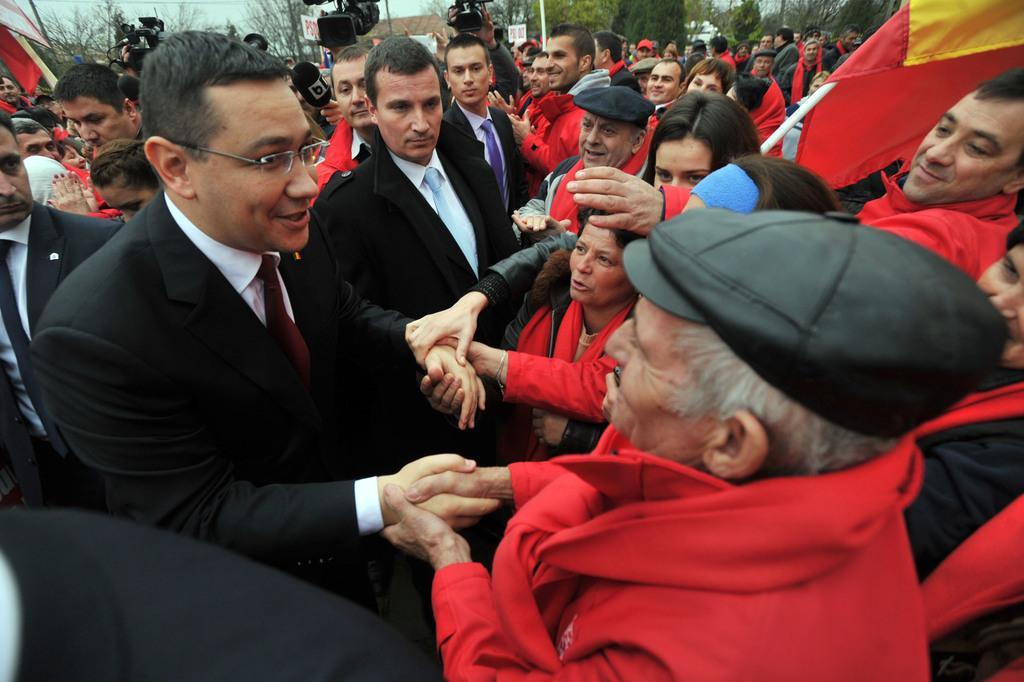In one or two sentences, can you explain what this image depicts? In this image there is a group of people trying to shake hands with a person. In the group there are people holding flags and placards. In the background of the image there are few people holding video cameras, behind them there are lamp posts, buildings and trees. 